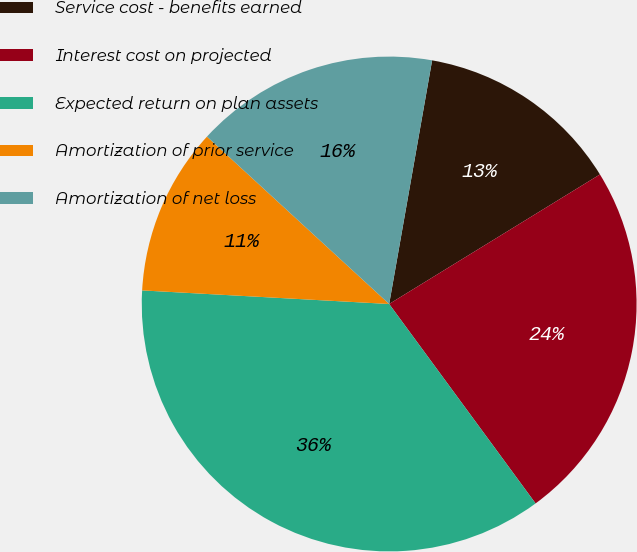<chart> <loc_0><loc_0><loc_500><loc_500><pie_chart><fcel>Service cost - benefits earned<fcel>Interest cost on projected<fcel>Expected return on plan assets<fcel>Amortization of prior service<fcel>Amortization of net loss<nl><fcel>13.45%<fcel>23.69%<fcel>35.95%<fcel>10.95%<fcel>15.95%<nl></chart> 